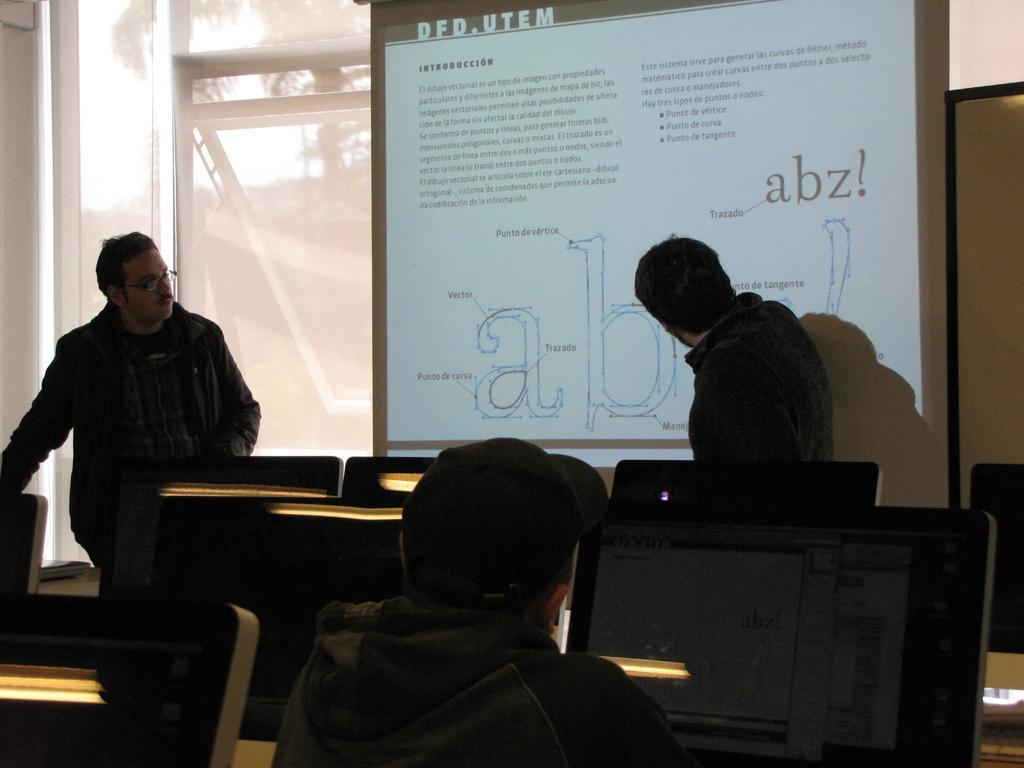Describe this image in one or two sentences. In this image we can see three persons, there are monitors on tables, there is a screen with some text on it, also we can see the wall, and windows. 